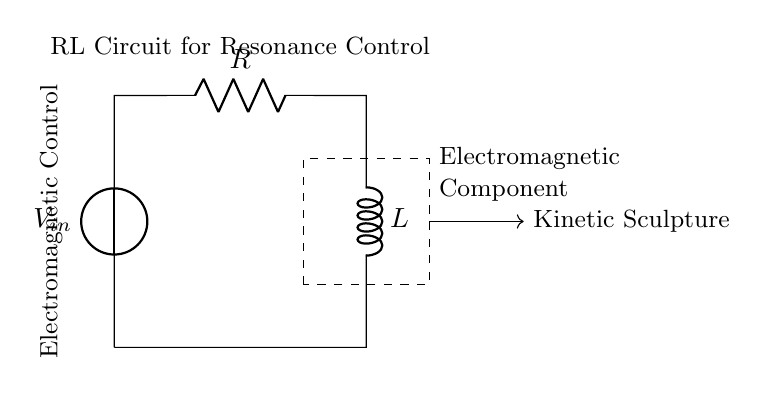What is the voltage source in this circuit? The voltage source is labeled as V_in, which supplies the input voltage for the RL circuit.
Answer: V_in What are the components labeled in the circuit? There are two main components in the circuit: a resistor (R) and an inductor (L). These are commonly used in RL circuits for resonance.
Answer: Resistor and Inductor What is the primary function of the RL circuit in this design? The RL circuit in this design is intended for controlling the resonance of kinetic sculptures, which suggests that it plays a role in tuning or stabilizing oscillations in the electromagnetic components.
Answer: Resonance control How does the current flow in this circuit? The current flows from the voltage source V_in, through the resistor R, and then through the inductor L before returning to the source, creating a closed loop.
Answer: Counterclockwise What is the purpose of the dashed rectangle in the circuit? The dashed rectangle signifies a grouping or containment of the electromagnetic components associated with the RL circuit, indicating that these components may interact with the circuit for controlling the sculpture's motion.
Answer: Electromagnetic components What type of circuit is this? This is an RL circuit, which consists of a resistor and an inductor and is used to analyze and control inductive loads and resonance in circuits.
Answer: RL circuit 